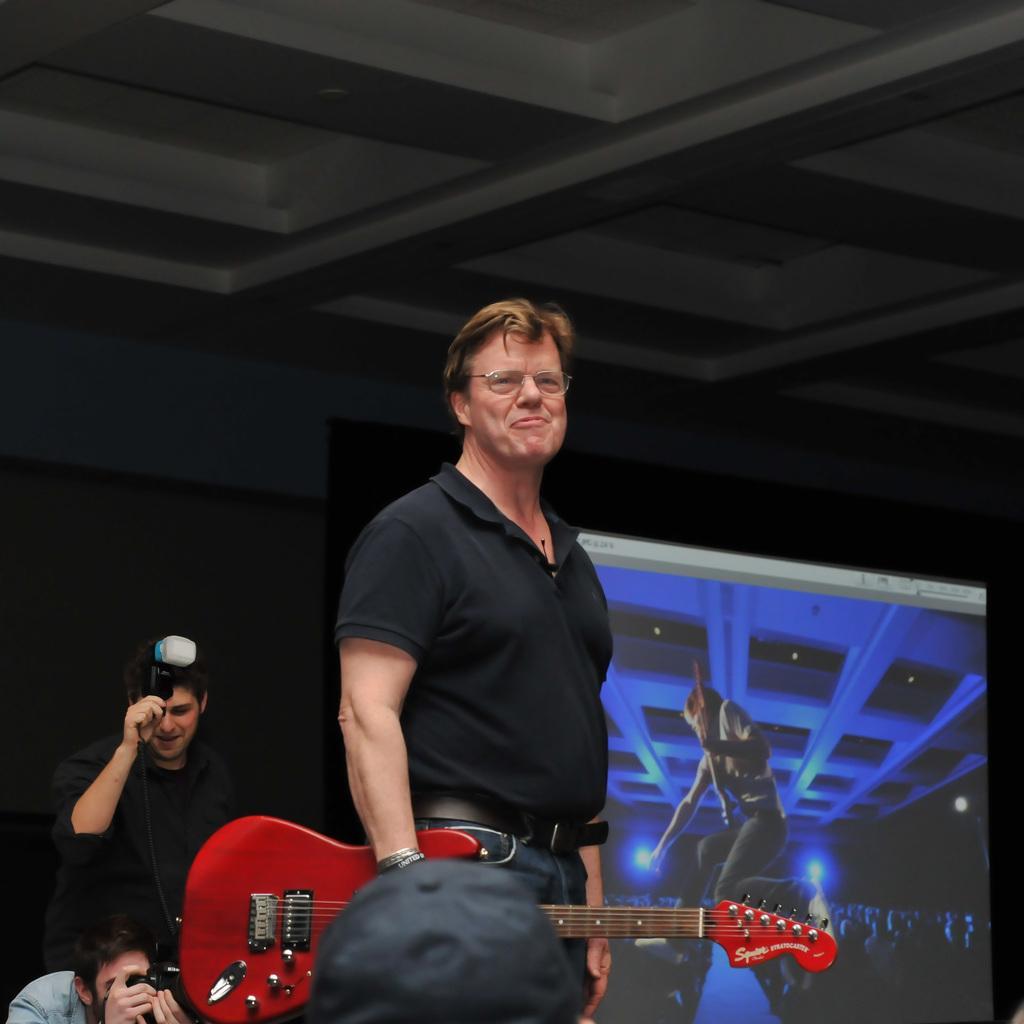Can you describe this image briefly? This is a picture taken in a room, the man in black t shirt holding a guitar. Background of this man is there are two other persons holding the cameras and a screen. Background of this people is a wall. 